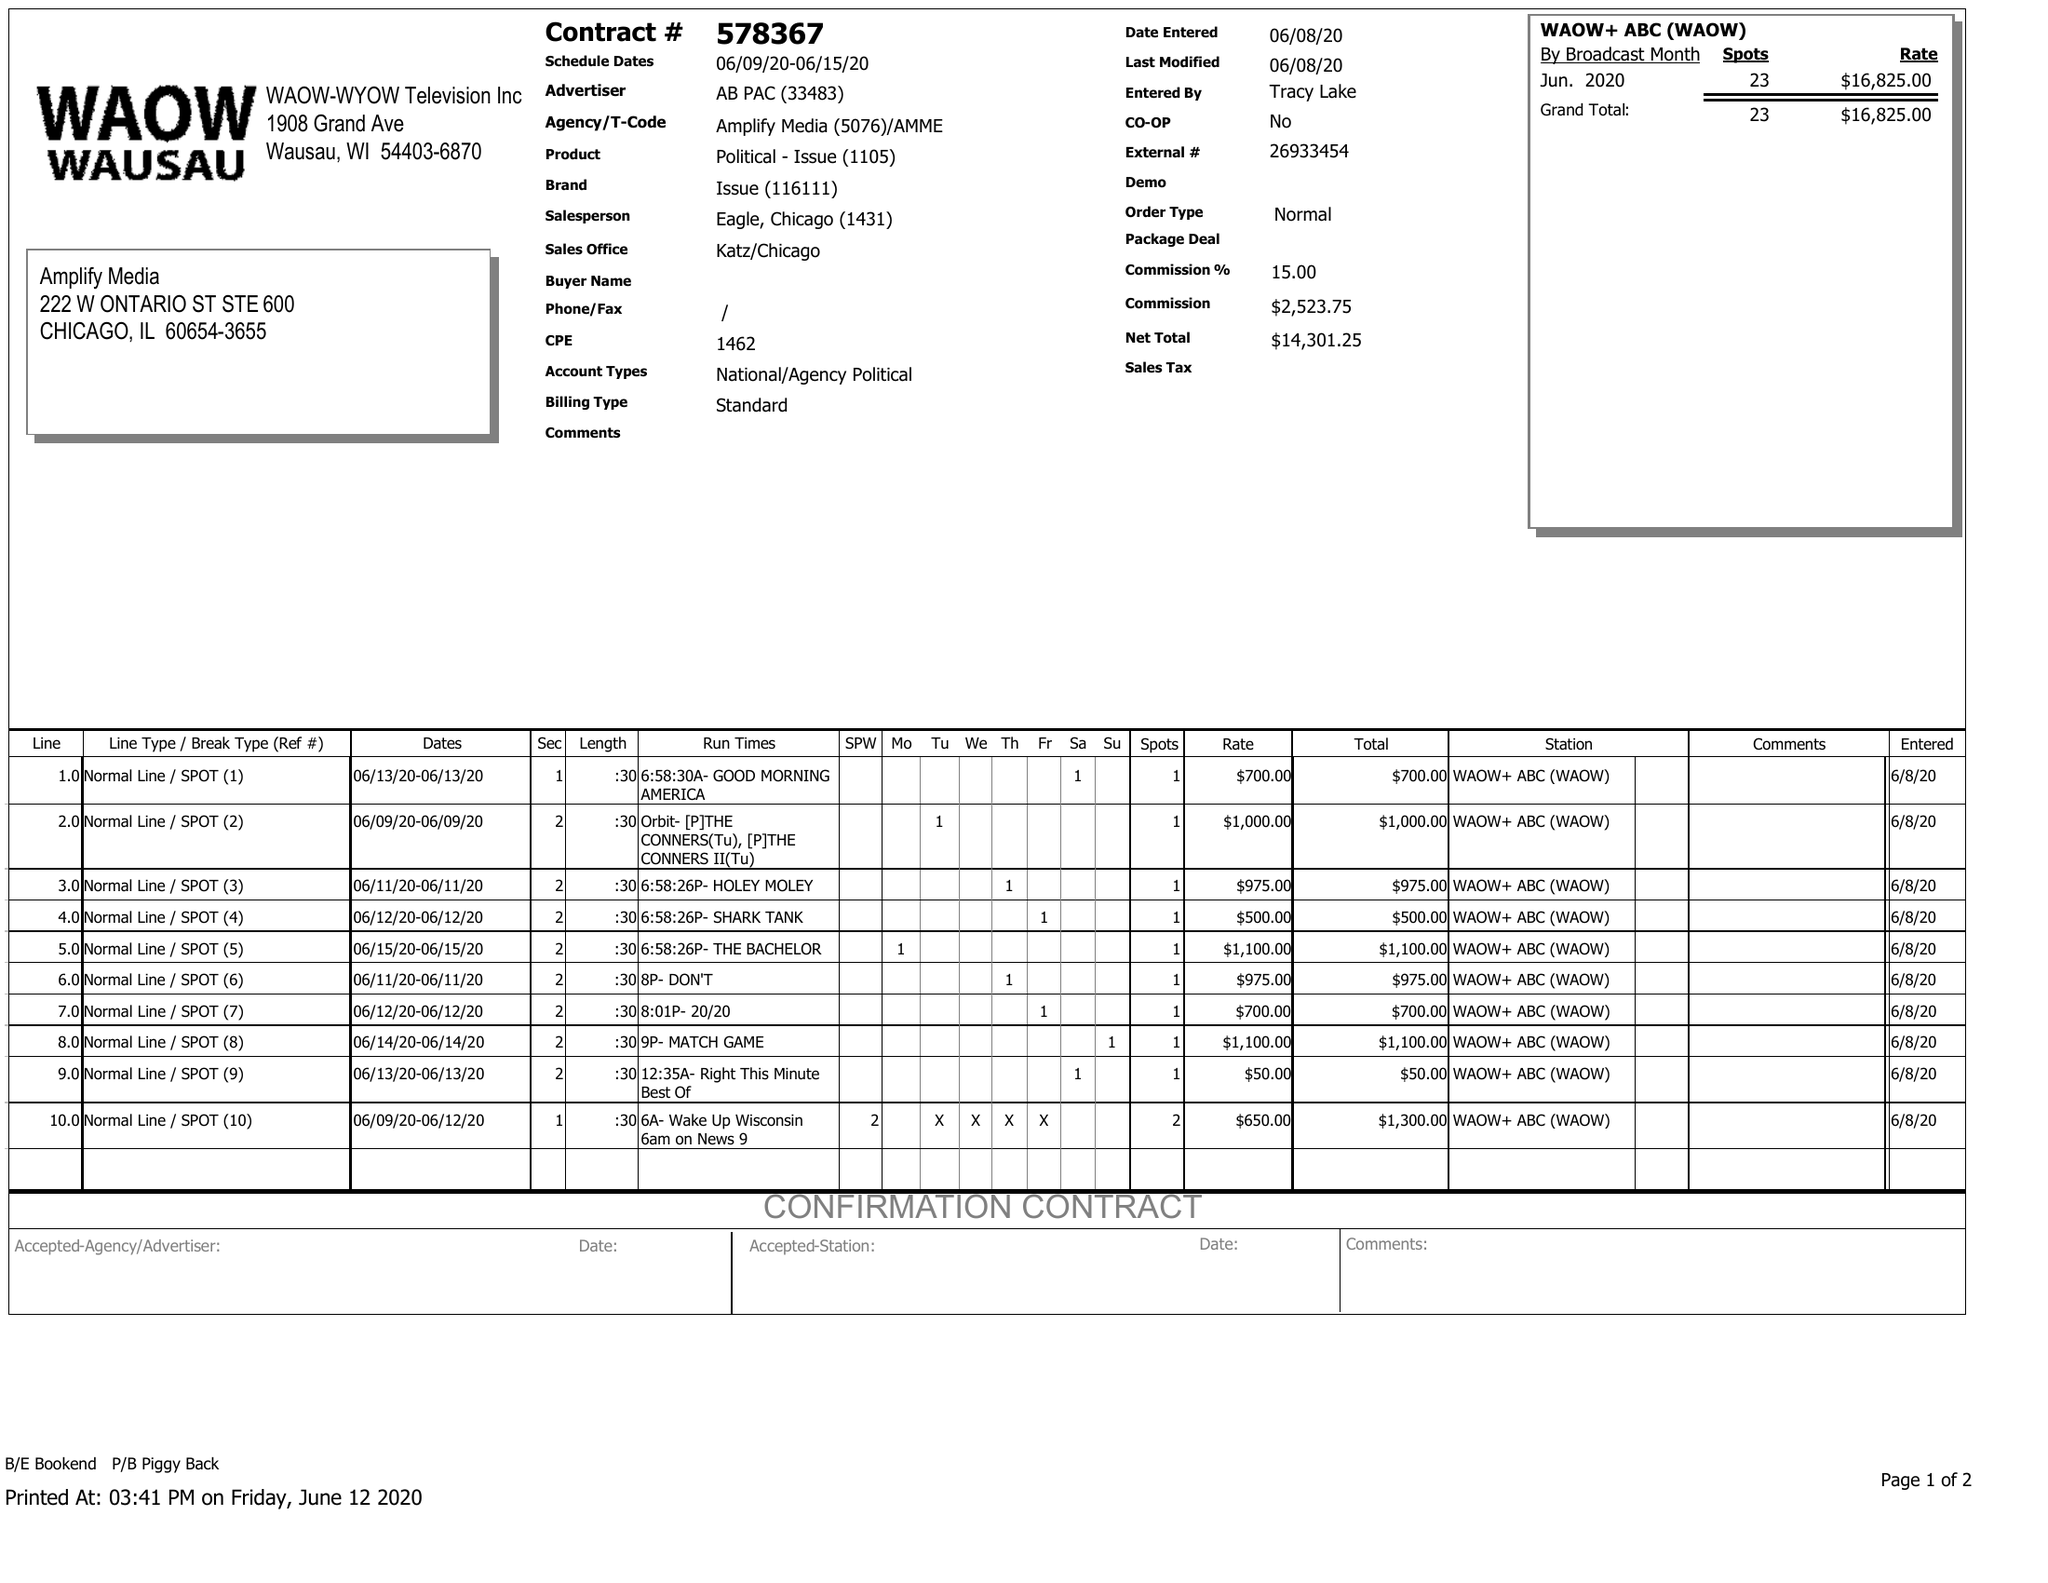What is the value for the gross_amount?
Answer the question using a single word or phrase. 16825.00 